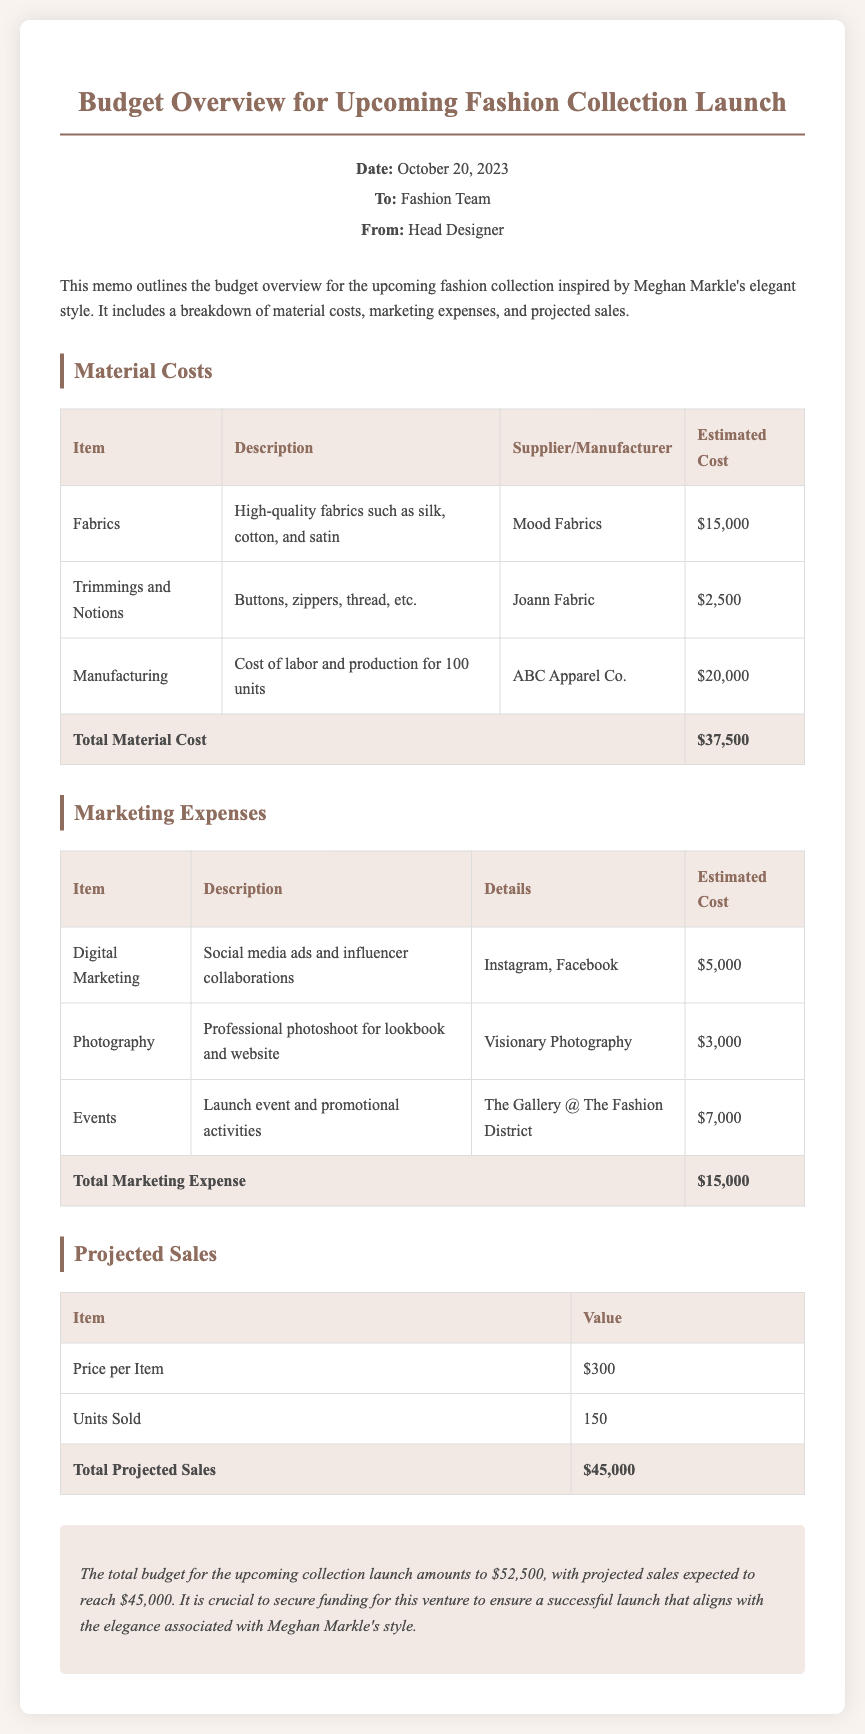what is the total material cost? The total material cost is presented at the end of the Material Costs section, which sums up the individual costs.
Answer: $37,500 what is the estimated cost of digital marketing? The estimated cost for digital marketing is mentioned in the Marketing Expenses section.
Answer: $5,000 how many units are projected to be sold? The projected units sold is specified in the Projected Sales section.
Answer: 150 who is the supplier for fabrics? The supplier of fabrics can be found in the Material Costs section, where it lists specific suppliers for each item.
Answer: Mood Fabrics what is the total budget for the upcoming collection launch? The total budget is calculated by adding material costs and marketing expenses, which is summarized at the end of the memo.
Answer: $52,500 what is the estimated cost for the photoshoot? The cost for the photoshoot is listed in the Marketing Expenses section with its associated details.
Answer: $3,000 what is the price per item? The price per item is provided in the Projected Sales section.
Answer: $300 who is the manufacturer for the manufacturing costs? The manufacturer for the manufacturing costs is indicated in the Material Costs section.
Answer: ABC Apparel Co 